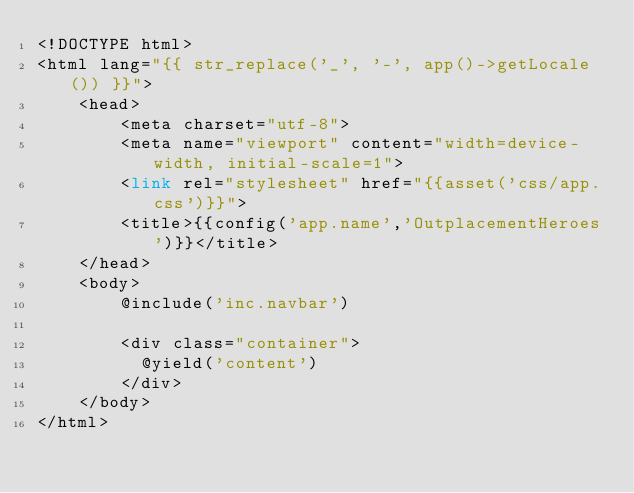<code> <loc_0><loc_0><loc_500><loc_500><_PHP_><!DOCTYPE html>
<html lang="{{ str_replace('_', '-', app()->getLocale()) }}">
    <head>
        <meta charset="utf-8">
        <meta name="viewport" content="width=device-width, initial-scale=1">
        <link rel="stylesheet" href="{{asset('css/app.css')}}">
        <title>{{config('app.name','OutplacementHeroes')}}</title>
    </head>
    <body>
        @include('inc.navbar')
        
        <div class="container">
          @yield('content')
        </div>
    </body>
</html></code> 